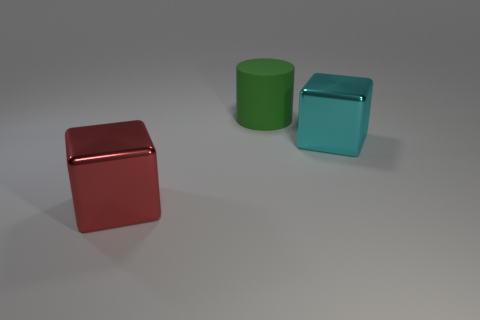Add 1 red balls. How many objects exist? 4 Subtract all cylinders. How many objects are left? 2 Add 3 big cylinders. How many big cylinders are left? 4 Add 1 big matte cylinders. How many big matte cylinders exist? 2 Subtract 0 purple cubes. How many objects are left? 3 Subtract all blue rubber things. Subtract all cylinders. How many objects are left? 2 